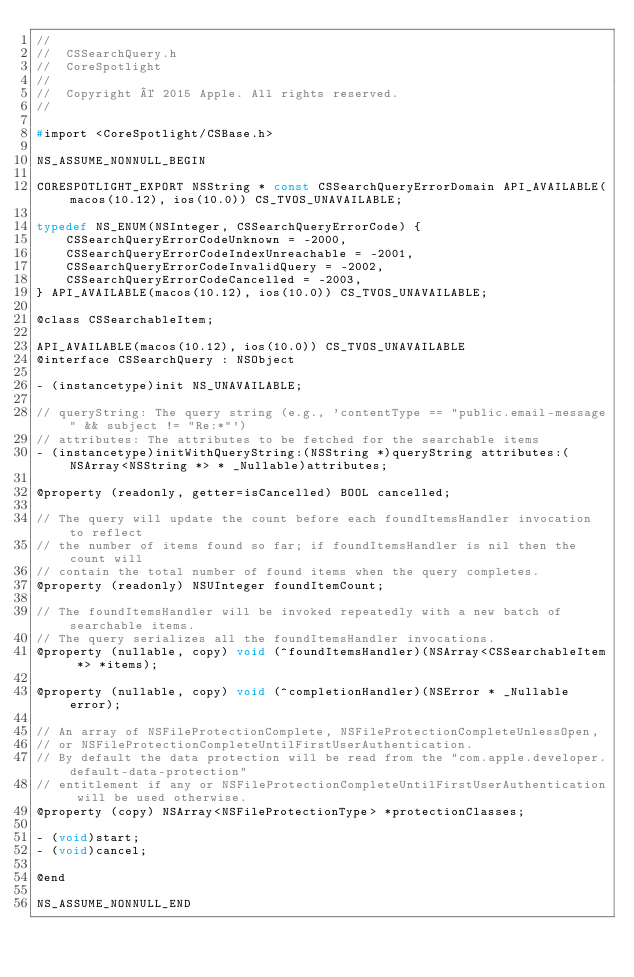Convert code to text. <code><loc_0><loc_0><loc_500><loc_500><_C_>//
//  CSSearchQuery.h
//  CoreSpotlight
//
//  Copyright © 2015 Apple. All rights reserved.
//

#import <CoreSpotlight/CSBase.h>

NS_ASSUME_NONNULL_BEGIN

CORESPOTLIGHT_EXPORT NSString * const CSSearchQueryErrorDomain API_AVAILABLE(macos(10.12), ios(10.0)) CS_TVOS_UNAVAILABLE;

typedef NS_ENUM(NSInteger, CSSearchQueryErrorCode) {
    CSSearchQueryErrorCodeUnknown = -2000,
    CSSearchQueryErrorCodeIndexUnreachable = -2001,
    CSSearchQueryErrorCodeInvalidQuery = -2002,
    CSSearchQueryErrorCodeCancelled = -2003,
} API_AVAILABLE(macos(10.12), ios(10.0)) CS_TVOS_UNAVAILABLE;

@class CSSearchableItem;

API_AVAILABLE(macos(10.12), ios(10.0)) CS_TVOS_UNAVAILABLE
@interface CSSearchQuery : NSObject

- (instancetype)init NS_UNAVAILABLE;

// queryString: The query string (e.g., 'contentType == "public.email-message" && subject != "Re:*"')
// attributes: The attributes to be fetched for the searchable items
- (instancetype)initWithQueryString:(NSString *)queryString attributes:(NSArray<NSString *> * _Nullable)attributes;

@property (readonly, getter=isCancelled) BOOL cancelled;

// The query will update the count before each foundItemsHandler invocation to reflect
// the number of items found so far; if foundItemsHandler is nil then the count will
// contain the total number of found items when the query completes.
@property (readonly) NSUInteger foundItemCount;

// The foundItemsHandler will be invoked repeatedly with a new batch of searchable items.
// The query serializes all the foundItemsHandler invocations.
@property (nullable, copy) void (^foundItemsHandler)(NSArray<CSSearchableItem *> *items);

@property (nullable, copy) void (^completionHandler)(NSError * _Nullable error);

// An array of NSFileProtectionComplete, NSFileProtectionCompleteUnlessOpen,
// or NSFileProtectionCompleteUntilFirstUserAuthentication.
// By default the data protection will be read from the "com.apple.developer.default-data-protection"
// entitlement if any or NSFileProtectionCompleteUntilFirstUserAuthentication will be used otherwise.
@property (copy) NSArray<NSFileProtectionType> *protectionClasses;

- (void)start;
- (void)cancel;

@end

NS_ASSUME_NONNULL_END
</code> 